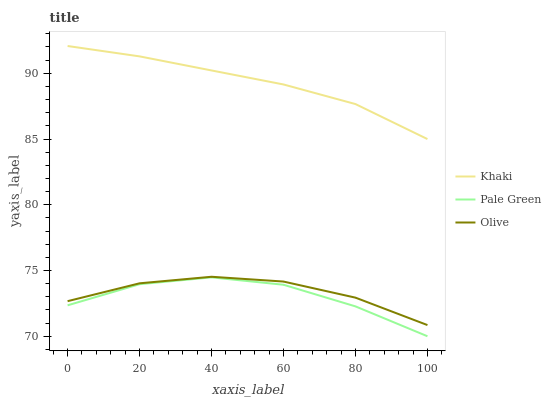Does Pale Green have the minimum area under the curve?
Answer yes or no. Yes. Does Khaki have the maximum area under the curve?
Answer yes or no. Yes. Does Khaki have the minimum area under the curve?
Answer yes or no. No. Does Pale Green have the maximum area under the curve?
Answer yes or no. No. Is Khaki the smoothest?
Answer yes or no. Yes. Is Pale Green the roughest?
Answer yes or no. Yes. Is Pale Green the smoothest?
Answer yes or no. No. Is Khaki the roughest?
Answer yes or no. No. Does Pale Green have the lowest value?
Answer yes or no. Yes. Does Khaki have the lowest value?
Answer yes or no. No. Does Khaki have the highest value?
Answer yes or no. Yes. Does Pale Green have the highest value?
Answer yes or no. No. Is Pale Green less than Olive?
Answer yes or no. Yes. Is Khaki greater than Olive?
Answer yes or no. Yes. Does Pale Green intersect Olive?
Answer yes or no. No. 